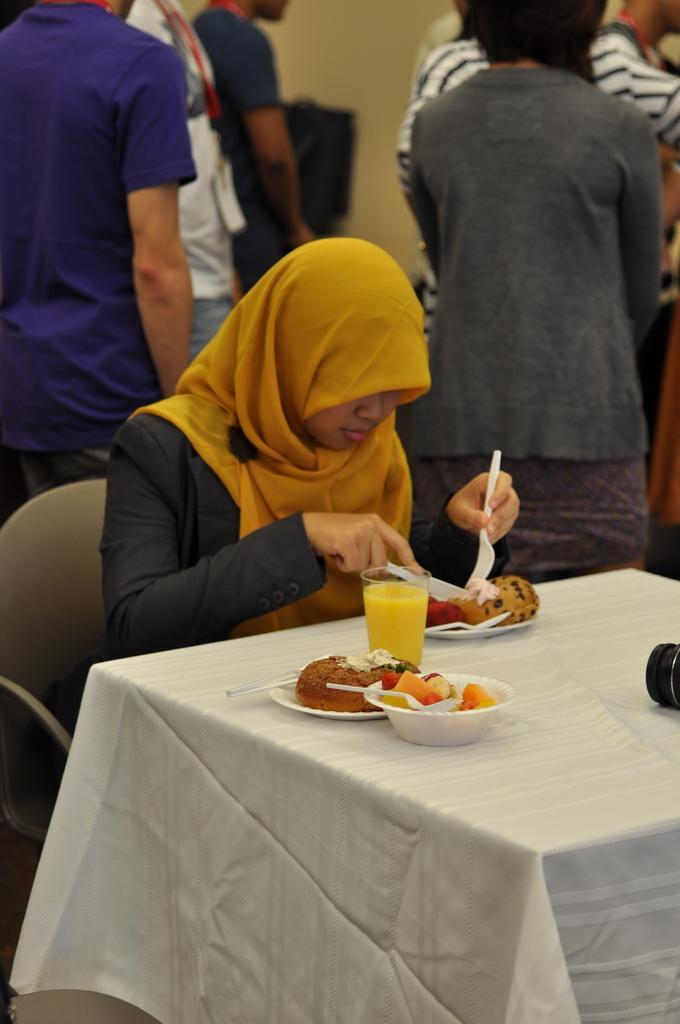Could you give a brief overview of what you see in this image? this picture shows few people are standing and a woman seated on the chair and holding a fork and knife in both the hands and we see some food in the plates and a glass of juice on the table 